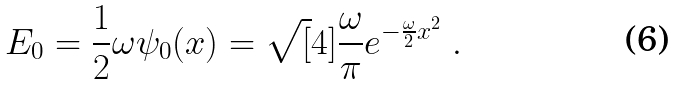Convert formula to latex. <formula><loc_0><loc_0><loc_500><loc_500>E _ { 0 } = \frac { 1 } { 2 } \omega \psi _ { 0 } ( x ) = \sqrt { [ } 4 ] { \frac { \omega } { \pi } } e ^ { - \frac { \omega } { 2 } x ^ { 2 } } \ .</formula> 